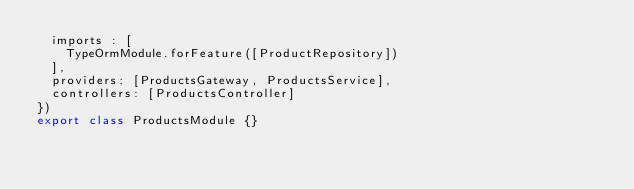<code> <loc_0><loc_0><loc_500><loc_500><_TypeScript_>  imports : [
    TypeOrmModule.forFeature([ProductRepository])
  ],
  providers: [ProductsGateway, ProductsService],
  controllers: [ProductsController]
})
export class ProductsModule {}
</code> 